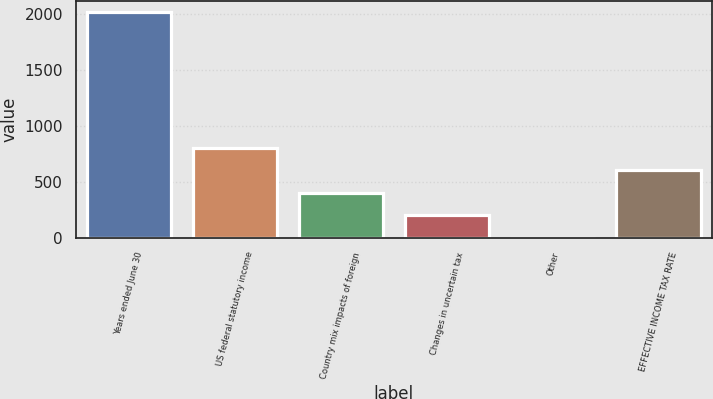Convert chart to OTSL. <chart><loc_0><loc_0><loc_500><loc_500><bar_chart><fcel>Years ended June 30<fcel>US federal statutory income<fcel>Country mix impacts of foreign<fcel>Changes in uncertain tax<fcel>Other<fcel>EFFECTIVE INCOME TAX RATE<nl><fcel>2016<fcel>806.64<fcel>403.52<fcel>201.96<fcel>0.4<fcel>605.08<nl></chart> 